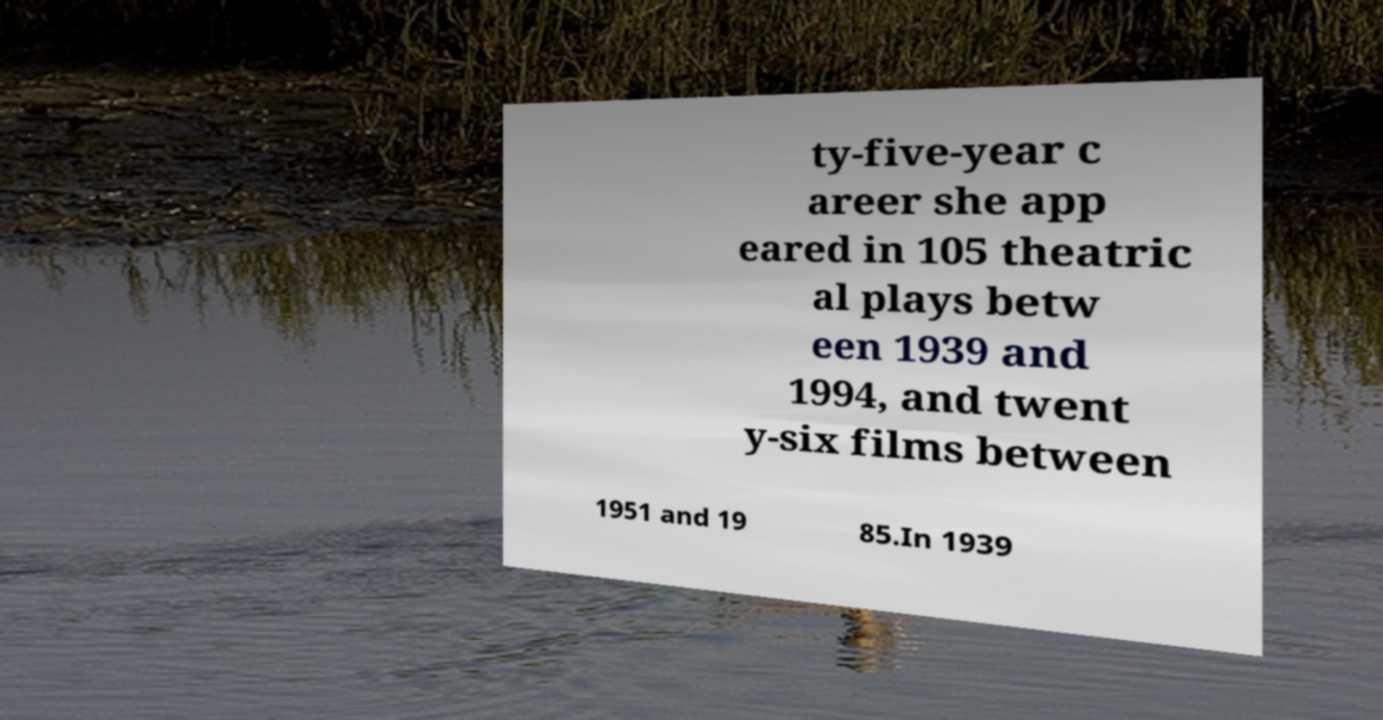Please read and relay the text visible in this image. What does it say? ty-five-year c areer she app eared in 105 theatric al plays betw een 1939 and 1994, and twent y-six films between 1951 and 19 85.In 1939 